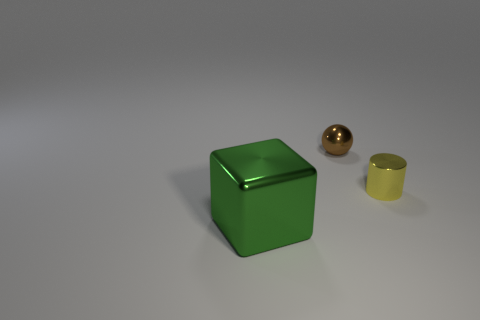Add 3 spheres. How many objects exist? 6 Subtract all cylinders. How many objects are left? 2 Subtract 1 brown balls. How many objects are left? 2 Subtract all brown metal things. Subtract all tiny balls. How many objects are left? 1 Add 3 big green cubes. How many big green cubes are left? 4 Add 2 brown balls. How many brown balls exist? 3 